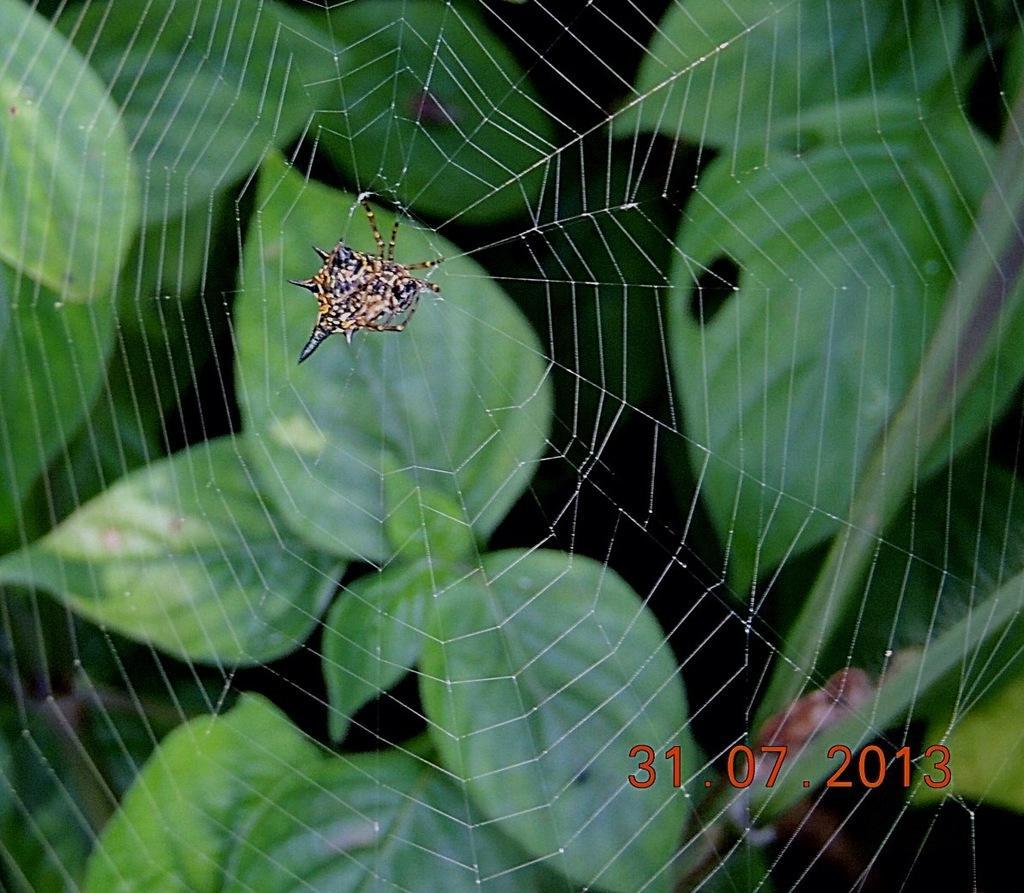Please provide a concise description of this image. In this picture I can see a spider insect. I can see leaves. 